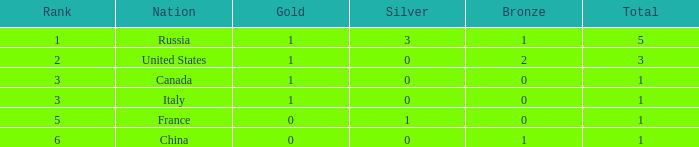Determine the complete number of golds when the sum is 1 and silver count is 1.0. 